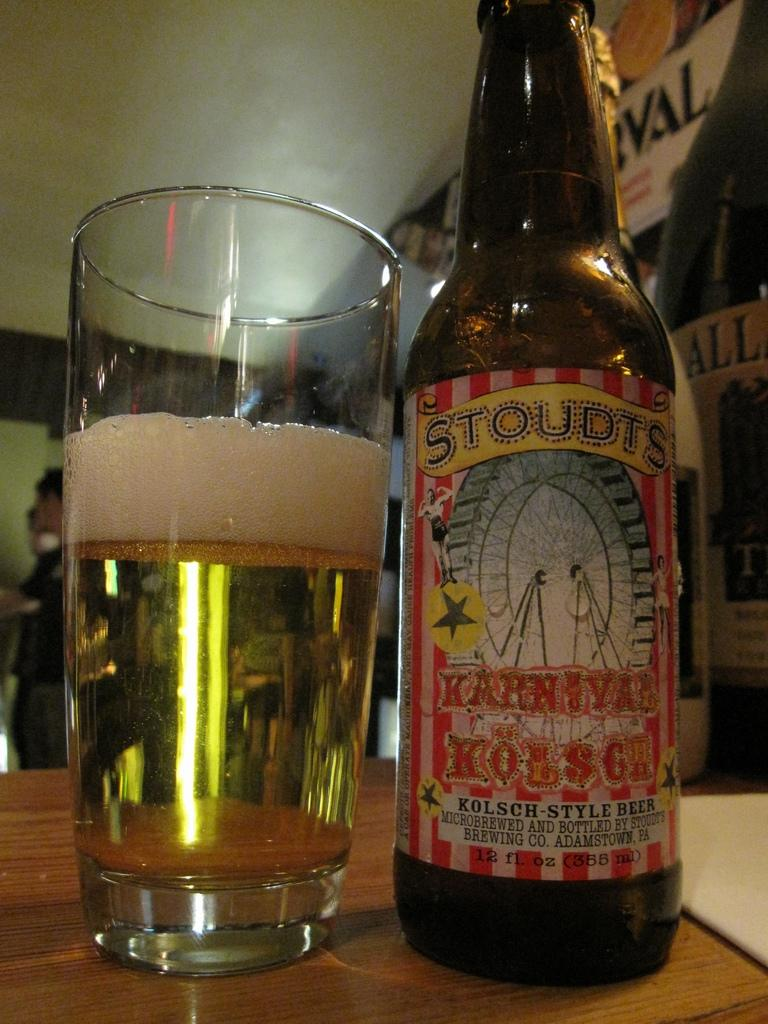<image>
Relay a brief, clear account of the picture shown. A bottle of Stoudts kolsch-style beer sits next to a glass half full of beer 